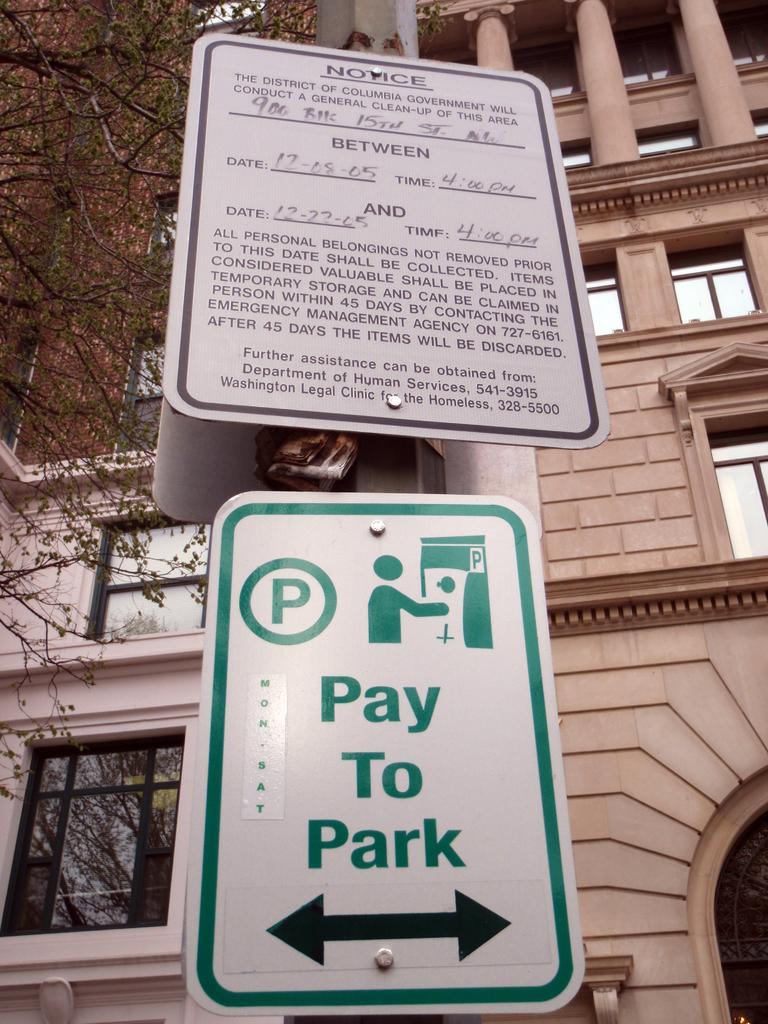Describe this image in one or two sentences. There is a sign board and a notice on a pole. On the left side there is a tree. In the back there is a building with windows and pillars. 